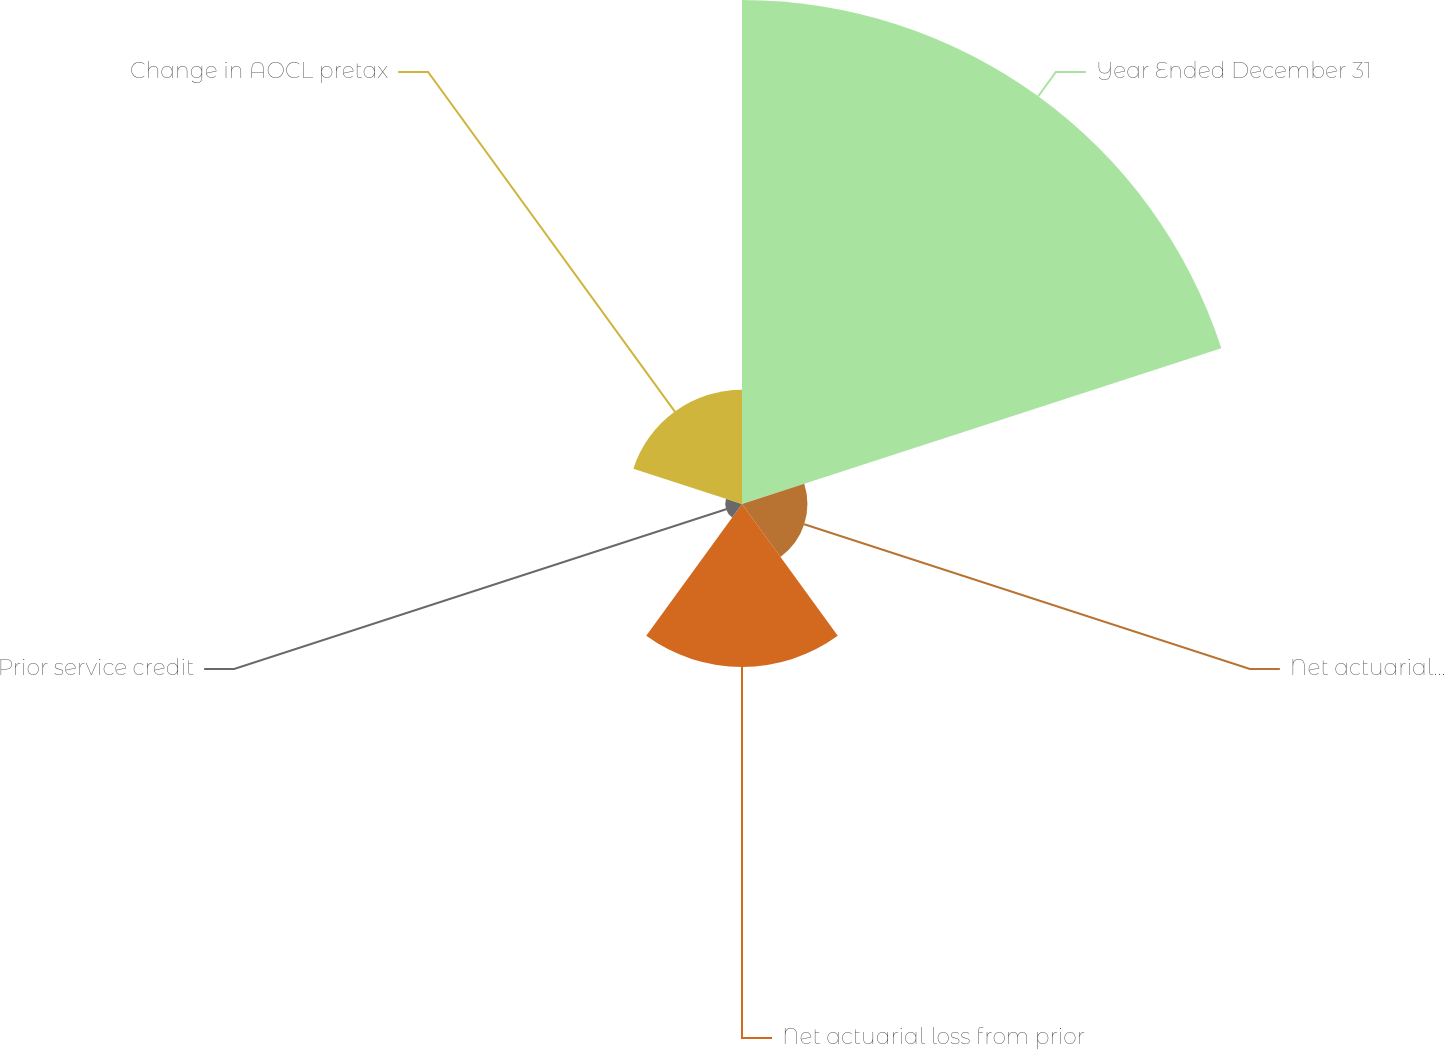Convert chart to OTSL. <chart><loc_0><loc_0><loc_500><loc_500><pie_chart><fcel>Year Ended December 31<fcel>Net actuarial loss (gain)<fcel>Net actuarial loss from prior<fcel>Prior service credit<fcel>Change in AOCL pretax<nl><fcel>58.38%<fcel>7.58%<fcel>18.87%<fcel>1.94%<fcel>13.23%<nl></chart> 